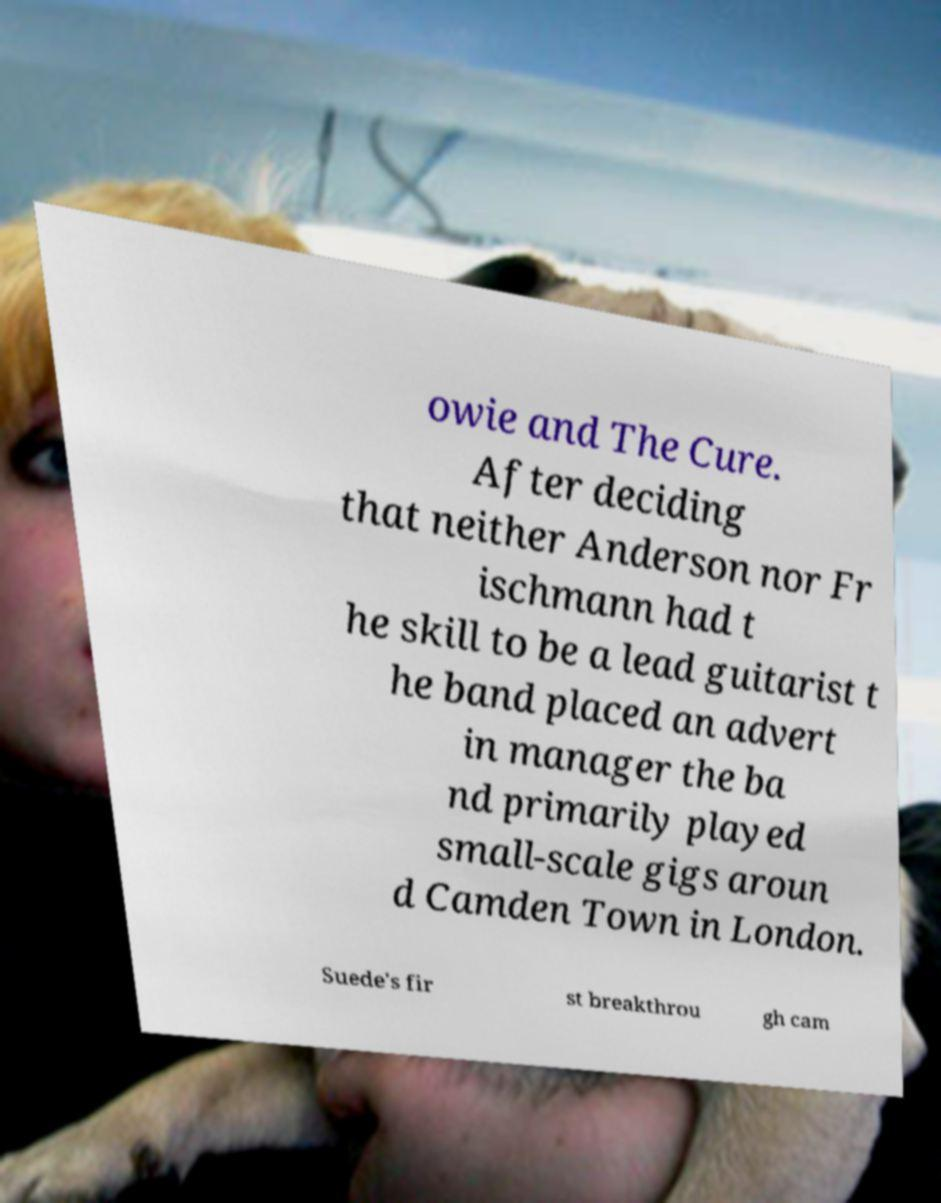What messages or text are displayed in this image? I need them in a readable, typed format. owie and The Cure. After deciding that neither Anderson nor Fr ischmann had t he skill to be a lead guitarist t he band placed an advert in manager the ba nd primarily played small-scale gigs aroun d Camden Town in London. Suede's fir st breakthrou gh cam 